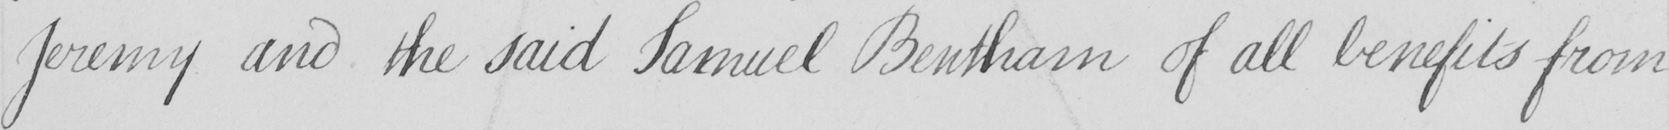What text is written in this handwritten line? Jeremy and the said Samuel Bentham of all benefits from 